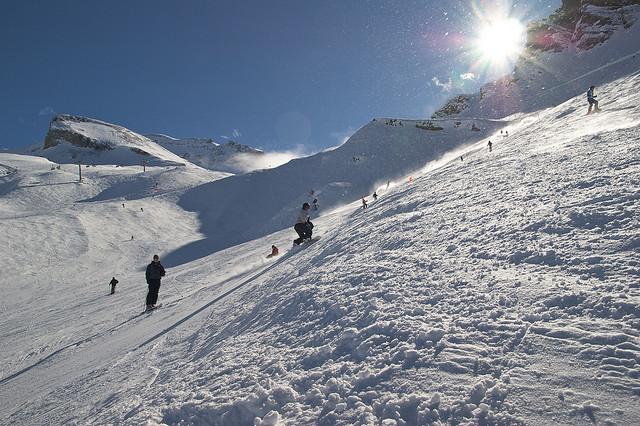Is this a summer scene?
Write a very short answer. No. What are the people doing?
Keep it brief. Snowboarding. Are there clouds in the sky?
Keep it brief. No. Is the sun out?
Keep it brief. Yes. 